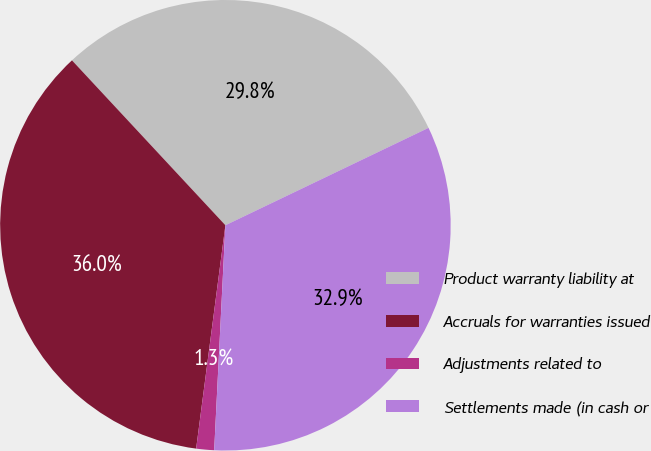<chart> <loc_0><loc_0><loc_500><loc_500><pie_chart><fcel>Product warranty liability at<fcel>Accruals for warranties issued<fcel>Adjustments related to<fcel>Settlements made (in cash or<nl><fcel>29.81%<fcel>36.0%<fcel>1.28%<fcel>32.91%<nl></chart> 